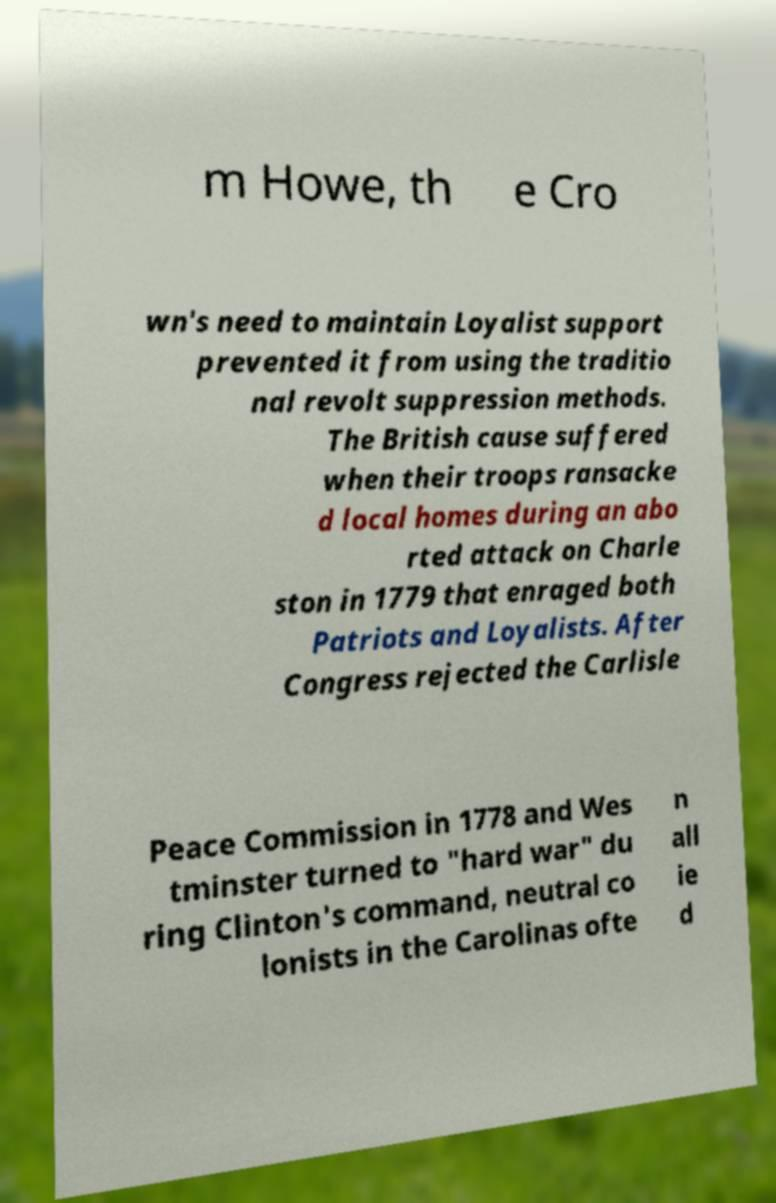Please read and relay the text visible in this image. What does it say? m Howe, th e Cro wn's need to maintain Loyalist support prevented it from using the traditio nal revolt suppression methods. The British cause suffered when their troops ransacke d local homes during an abo rted attack on Charle ston in 1779 that enraged both Patriots and Loyalists. After Congress rejected the Carlisle Peace Commission in 1778 and Wes tminster turned to "hard war" du ring Clinton's command, neutral co lonists in the Carolinas ofte n all ie d 